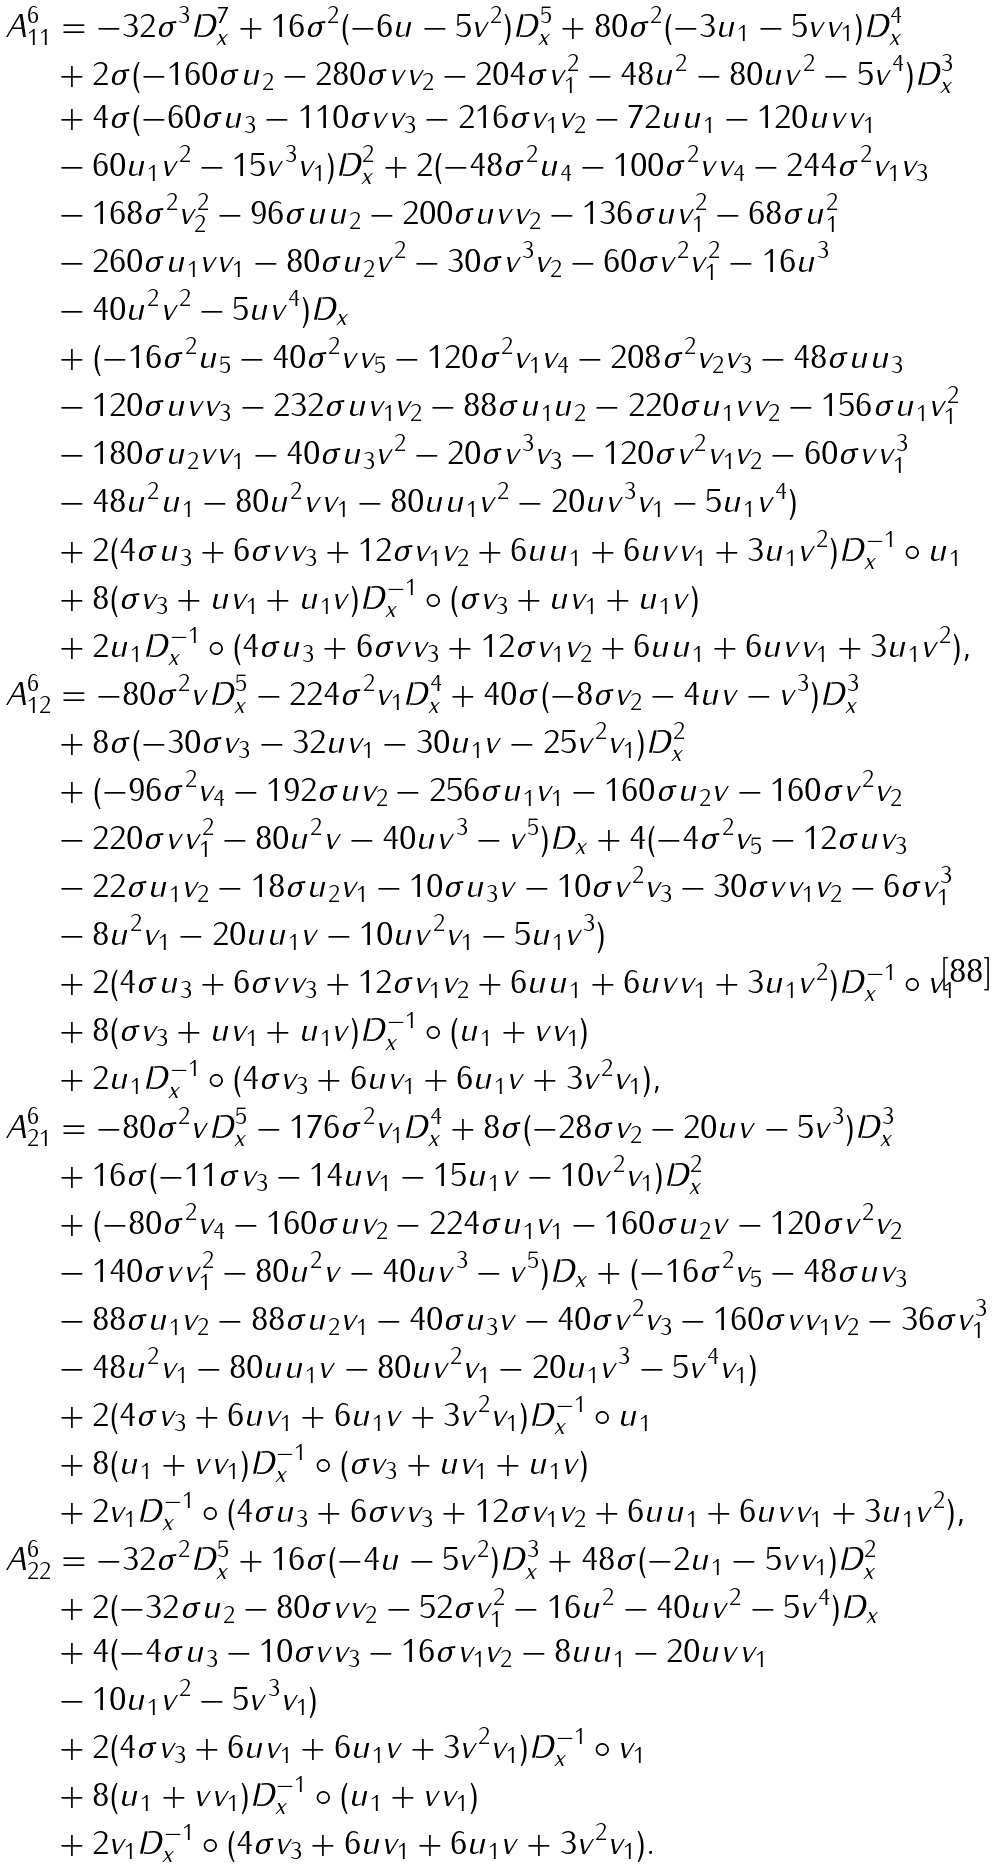<formula> <loc_0><loc_0><loc_500><loc_500>A ^ { 6 } _ { 1 1 } & = - 3 2 \sigma ^ { 3 } D _ { x } ^ { 7 } + 1 6 \sigma ^ { 2 } ( - 6 u - 5 v ^ { 2 } ) D _ { x } ^ { 5 } + 8 0 \sigma ^ { 2 } ( - 3 u _ { 1 } - 5 v v _ { 1 } ) D _ { x } ^ { 4 } \\ & + 2 \sigma ( - 1 6 0 \sigma u _ { 2 } - 2 8 0 \sigma v v _ { 2 } - 2 0 4 \sigma v _ { 1 } ^ { 2 } - 4 8 u ^ { 2 } - 8 0 u v ^ { 2 } - 5 v ^ { 4 } ) D _ { x } ^ { 3 } \\ & + 4 \sigma ( - 6 0 \sigma u _ { 3 } - 1 1 0 \sigma v v _ { 3 } - 2 1 6 \sigma v _ { 1 } v _ { 2 } - 7 2 u u _ { 1 } - 1 2 0 u v v _ { 1 } \\ & - 6 0 u _ { 1 } v ^ { 2 } - 1 5 v ^ { 3 } v _ { 1 } ) D _ { x } ^ { 2 } + 2 ( - 4 8 \sigma ^ { 2 } u _ { 4 } - 1 0 0 \sigma ^ { 2 } v v _ { 4 } - 2 4 4 \sigma ^ { 2 } v _ { 1 } v _ { 3 } \\ & - 1 6 8 \sigma ^ { 2 } v _ { 2 } ^ { 2 } - 9 6 \sigma u u _ { 2 } - 2 0 0 \sigma u v v _ { 2 } - 1 3 6 \sigma u v _ { 1 } ^ { 2 } - 6 8 \sigma u _ { 1 } ^ { 2 } \\ & - 2 6 0 \sigma u _ { 1 } v v _ { 1 } - 8 0 \sigma u _ { 2 } v ^ { 2 } - 3 0 \sigma v ^ { 3 } v _ { 2 } - 6 0 \sigma v ^ { 2 } v _ { 1 } ^ { 2 } - 1 6 u ^ { 3 } \\ & - 4 0 u ^ { 2 } v ^ { 2 } - 5 u v ^ { 4 } ) D _ { x } \\ & + ( - 1 6 \sigma ^ { 2 } u _ { 5 } - 4 0 \sigma ^ { 2 } v v _ { 5 } - 1 2 0 \sigma ^ { 2 } v _ { 1 } v _ { 4 } - 2 0 8 \sigma ^ { 2 } v _ { 2 } v _ { 3 } - 4 8 \sigma u u _ { 3 } \\ & - 1 2 0 \sigma u v v _ { 3 } - 2 3 2 \sigma u v _ { 1 } v _ { 2 } - 8 8 \sigma u _ { 1 } u _ { 2 } - 2 2 0 \sigma u _ { 1 } v v _ { 2 } - 1 5 6 \sigma u _ { 1 } v _ { 1 } ^ { 2 } \\ & - 1 8 0 \sigma u _ { 2 } v v _ { 1 } - 4 0 \sigma u _ { 3 } v ^ { 2 } - 2 0 \sigma v ^ { 3 } v _ { 3 } - 1 2 0 \sigma v ^ { 2 } v _ { 1 } v _ { 2 } - 6 0 \sigma v v _ { 1 } ^ { 3 } \\ & - 4 8 u ^ { 2 } u _ { 1 } - 8 0 u ^ { 2 } v v _ { 1 } - 8 0 u u _ { 1 } v ^ { 2 } - 2 0 u v ^ { 3 } v _ { 1 } - 5 u _ { 1 } v ^ { 4 } ) \\ & + 2 ( 4 \sigma u _ { 3 } + 6 \sigma v v _ { 3 } + 1 2 \sigma v _ { 1 } v _ { 2 } + 6 u u _ { 1 } + 6 u v v _ { 1 } + 3 u _ { 1 } v ^ { 2 } ) D _ { x } ^ { - 1 } \circ u _ { 1 } \\ & + 8 ( \sigma v _ { 3 } + u v _ { 1 } + u _ { 1 } v ) D _ { x } ^ { - 1 } \circ ( \sigma v _ { 3 } + u v _ { 1 } + u _ { 1 } v ) \\ & + 2 u _ { 1 } D _ { x } ^ { - 1 } \circ ( 4 \sigma u _ { 3 } + 6 \sigma v v _ { 3 } + 1 2 \sigma v _ { 1 } v _ { 2 } + 6 u u _ { 1 } + 6 u v v _ { 1 } + 3 u _ { 1 } v ^ { 2 } ) , \\ A ^ { 6 } _ { 1 2 } & = - 8 0 \sigma ^ { 2 } v D _ { x } ^ { 5 } - 2 2 4 \sigma ^ { 2 } v _ { 1 } D _ { x } ^ { 4 } + 4 0 \sigma ( - 8 \sigma v _ { 2 } - 4 u v - v ^ { 3 } ) D _ { x } ^ { 3 } \\ & + 8 \sigma ( - 3 0 \sigma v _ { 3 } - 3 2 u v _ { 1 } - 3 0 u _ { 1 } v - 2 5 v ^ { 2 } v _ { 1 } ) D _ { x } ^ { 2 } \\ & + ( - 9 6 \sigma ^ { 2 } v _ { 4 } - 1 9 2 \sigma u v _ { 2 } - 2 5 6 \sigma u _ { 1 } v _ { 1 } - 1 6 0 \sigma u _ { 2 } v - 1 6 0 \sigma v ^ { 2 } v _ { 2 } \\ & - 2 2 0 \sigma v v _ { 1 } ^ { 2 } - 8 0 u ^ { 2 } v - 4 0 u v ^ { 3 } - v ^ { 5 } ) D _ { x } + 4 ( - 4 \sigma ^ { 2 } v _ { 5 } - 1 2 \sigma u v _ { 3 } \\ & - 2 2 \sigma u _ { 1 } v _ { 2 } - 1 8 \sigma u _ { 2 } v _ { 1 } - 1 0 \sigma u _ { 3 } v - 1 0 \sigma v ^ { 2 } v _ { 3 } - 3 0 \sigma v v _ { 1 } v _ { 2 } - 6 \sigma v _ { 1 } ^ { 3 } \\ & - 8 u ^ { 2 } v _ { 1 } - 2 0 u u _ { 1 } v - 1 0 u v ^ { 2 } v _ { 1 } - 5 u _ { 1 } v ^ { 3 } ) \\ & + 2 ( 4 \sigma u _ { 3 } + 6 \sigma v v _ { 3 } + 1 2 \sigma v _ { 1 } v _ { 2 } + 6 u u _ { 1 } + 6 u v v _ { 1 } + 3 u _ { 1 } v ^ { 2 } ) D _ { x } ^ { - 1 } \circ v _ { 1 } \\ & + 8 ( \sigma v _ { 3 } + u v _ { 1 } + u _ { 1 } v ) D _ { x } ^ { - 1 } \circ ( u _ { 1 } + v v _ { 1 } ) \\ & + 2 u _ { 1 } D _ { x } ^ { - 1 } \circ ( 4 \sigma v _ { 3 } + 6 u v _ { 1 } + 6 u _ { 1 } v + 3 v ^ { 2 } v _ { 1 } ) , \\ A ^ { 6 } _ { 2 1 } & = - 8 0 \sigma ^ { 2 } v D _ { x } ^ { 5 } - 1 7 6 \sigma ^ { 2 } v _ { 1 } D _ { x } ^ { 4 } + 8 \sigma ( - 2 8 \sigma v _ { 2 } - 2 0 u v - 5 v ^ { 3 } ) D _ { x } ^ { 3 } \\ & + 1 6 \sigma ( - 1 1 \sigma v _ { 3 } - 1 4 u v _ { 1 } - 1 5 u _ { 1 } v - 1 0 v ^ { 2 } v _ { 1 } ) D _ { x } ^ { 2 } \\ & + ( - 8 0 \sigma ^ { 2 } v _ { 4 } - 1 6 0 \sigma u v _ { 2 } - 2 2 4 \sigma u _ { 1 } v _ { 1 } - 1 6 0 \sigma u _ { 2 } v - 1 2 0 \sigma v ^ { 2 } v _ { 2 } \\ & - 1 4 0 \sigma v v _ { 1 } ^ { 2 } - 8 0 u ^ { 2 } v - 4 0 u v ^ { 3 } - v ^ { 5 } ) D _ { x } + ( - 1 6 \sigma ^ { 2 } v _ { 5 } - 4 8 \sigma u v _ { 3 } \\ & - 8 8 \sigma u _ { 1 } v _ { 2 } - 8 8 \sigma u _ { 2 } v _ { 1 } - 4 0 \sigma u _ { 3 } v - 4 0 \sigma v ^ { 2 } v _ { 3 } - 1 6 0 \sigma v v _ { 1 } v _ { 2 } - 3 6 \sigma v _ { 1 } ^ { 3 } \\ & - 4 8 u ^ { 2 } v _ { 1 } - 8 0 u u _ { 1 } v - 8 0 u v ^ { 2 } v _ { 1 } - 2 0 u _ { 1 } v ^ { 3 } - 5 v ^ { 4 } v _ { 1 } ) \\ & + 2 ( 4 \sigma v _ { 3 } + 6 u v _ { 1 } + 6 u _ { 1 } v + 3 v ^ { 2 } v _ { 1 } ) D _ { x } ^ { - 1 } \circ u _ { 1 } \\ & + 8 ( u _ { 1 } + v v _ { 1 } ) D _ { x } ^ { - 1 } \circ ( \sigma v _ { 3 } + u v _ { 1 } + u _ { 1 } v ) \\ & + 2 v _ { 1 } D _ { x } ^ { - 1 } \circ ( 4 \sigma u _ { 3 } + 6 \sigma v v _ { 3 } + 1 2 \sigma v _ { 1 } v _ { 2 } + 6 u u _ { 1 } + 6 u v v _ { 1 } + 3 u _ { 1 } v ^ { 2 } ) , \\ A ^ { 6 } _ { 2 2 } & = - 3 2 \sigma ^ { 2 } D _ { x } ^ { 5 } + 1 6 \sigma ( - 4 u - 5 v ^ { 2 } ) D _ { x } ^ { 3 } + 4 8 \sigma ( - 2 u _ { 1 } - 5 v v _ { 1 } ) D _ { x } ^ { 2 } \\ & + 2 ( - 3 2 \sigma u _ { 2 } - 8 0 \sigma v v _ { 2 } - 5 2 \sigma v _ { 1 } ^ { 2 } - 1 6 u ^ { 2 } - 4 0 u v ^ { 2 } - 5 v ^ { 4 } ) D _ { x } \\ & + 4 ( - 4 \sigma u _ { 3 } - 1 0 \sigma v v _ { 3 } - 1 6 \sigma v _ { 1 } v _ { 2 } - 8 u u _ { 1 } - 2 0 u v v _ { 1 } \\ & - 1 0 u _ { 1 } v ^ { 2 } - 5 v ^ { 3 } v _ { 1 } ) \\ & + 2 ( 4 \sigma v _ { 3 } + 6 u v _ { 1 } + 6 u _ { 1 } v + 3 v ^ { 2 } v _ { 1 } ) D _ { x } ^ { - 1 } \circ v _ { 1 } \\ & + 8 ( u _ { 1 } + v v _ { 1 } ) D _ { x } ^ { - 1 } \circ ( u _ { 1 } + v v _ { 1 } ) \\ & + 2 v _ { 1 } D _ { x } ^ { - 1 } \circ ( 4 \sigma v _ { 3 } + 6 u v _ { 1 } + 6 u _ { 1 } v + 3 v ^ { 2 } v _ { 1 } ) .</formula> 